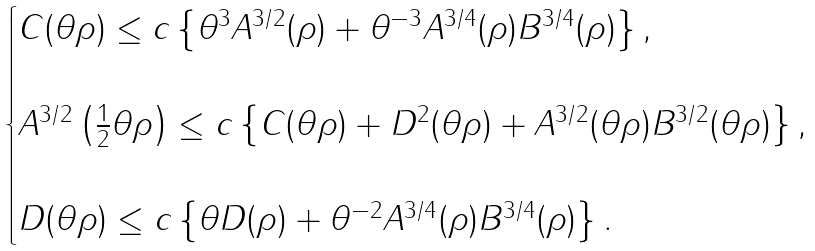Convert formula to latex. <formula><loc_0><loc_0><loc_500><loc_500>\begin{cases} C ( \theta \rho ) \leq c \left \{ \theta ^ { 3 } A ^ { 3 / 2 } ( \rho ) + \theta ^ { - 3 } A ^ { 3 / 4 } ( \rho ) B ^ { 3 / 4 } ( \rho ) \right \} , \\ \\ A ^ { 3 / 2 } \left ( \frac { 1 } { 2 } \theta \rho \right ) \leq c \left \{ C ( \theta \rho ) + D ^ { 2 } ( \theta \rho ) + A ^ { 3 / 2 } ( \theta \rho ) B ^ { 3 / 2 } ( \theta \rho ) \right \} , \\ \\ D ( \theta \rho ) \leq c \left \{ \theta D ( \rho ) + \theta ^ { - 2 } A ^ { 3 / 4 } ( \rho ) B ^ { 3 / 4 } ( \rho ) \right \} . \end{cases}</formula> 